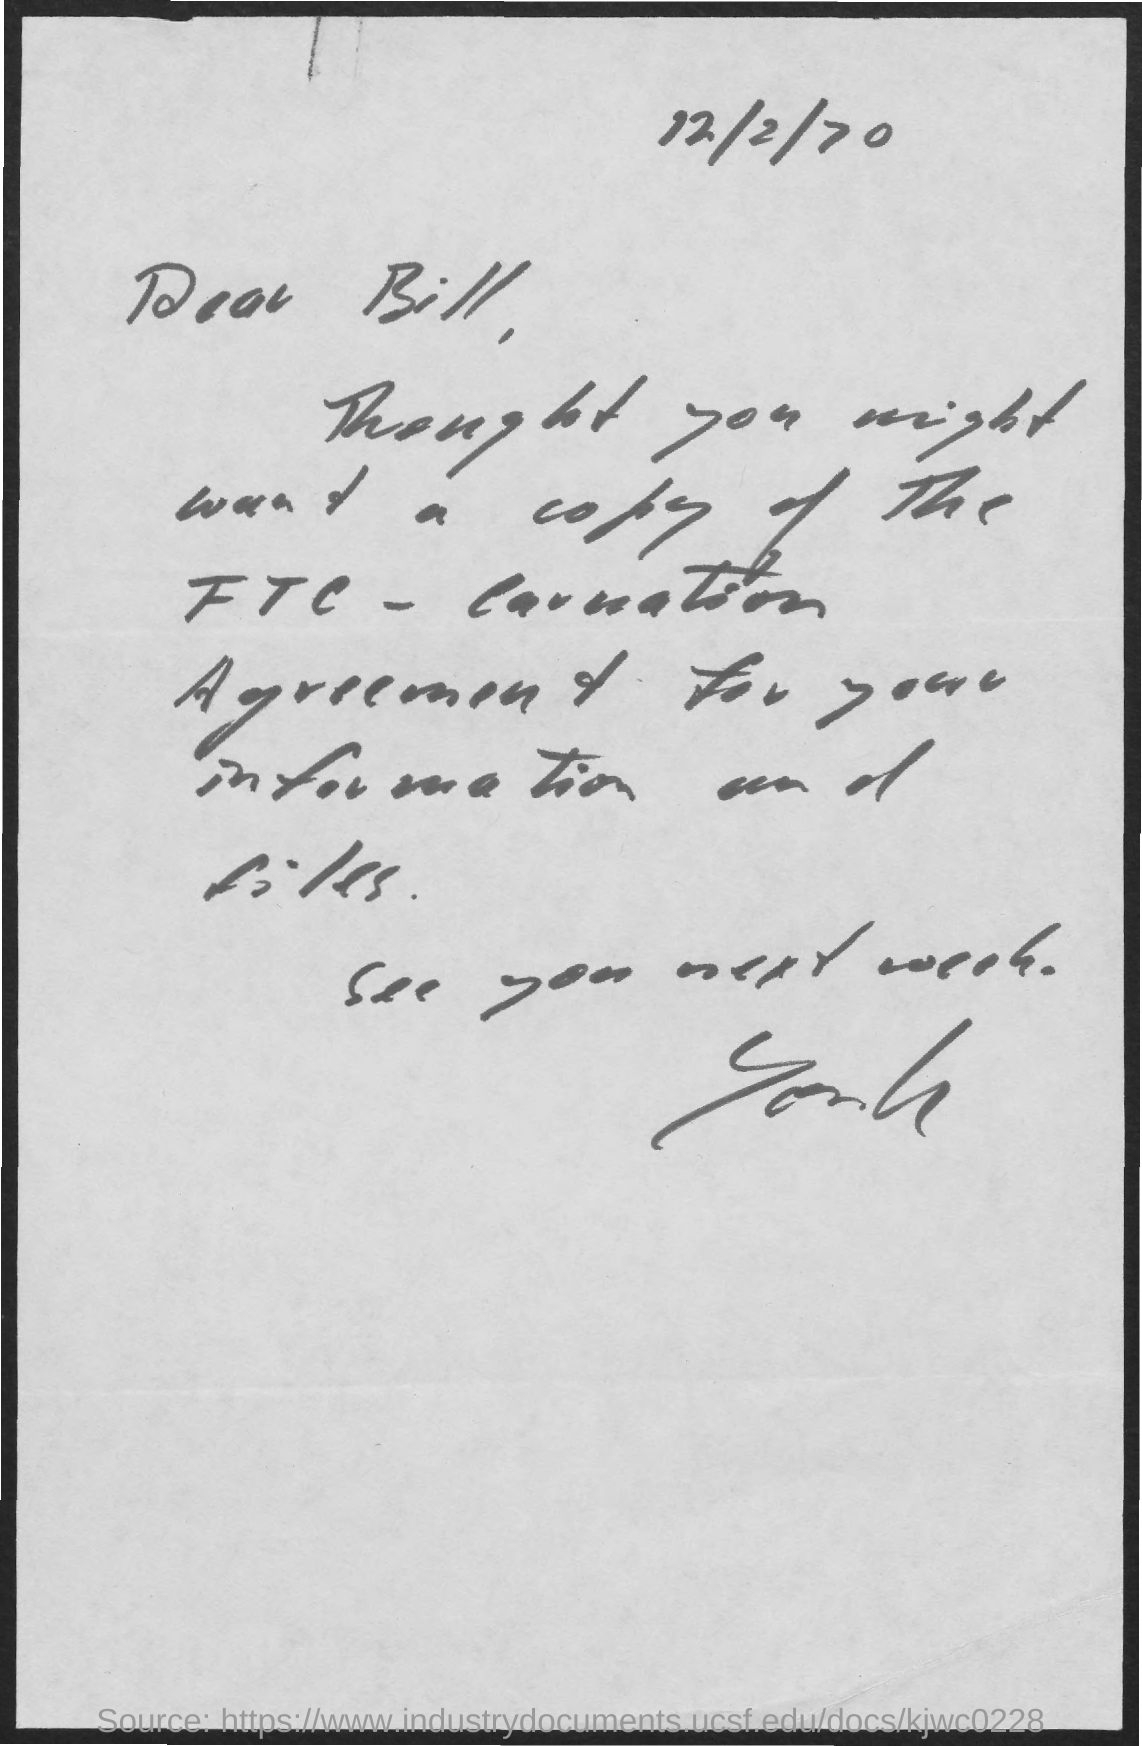Highlight a few significant elements in this photo. The date on the document is December 2, 1970. The letter is addressed to Bill. 